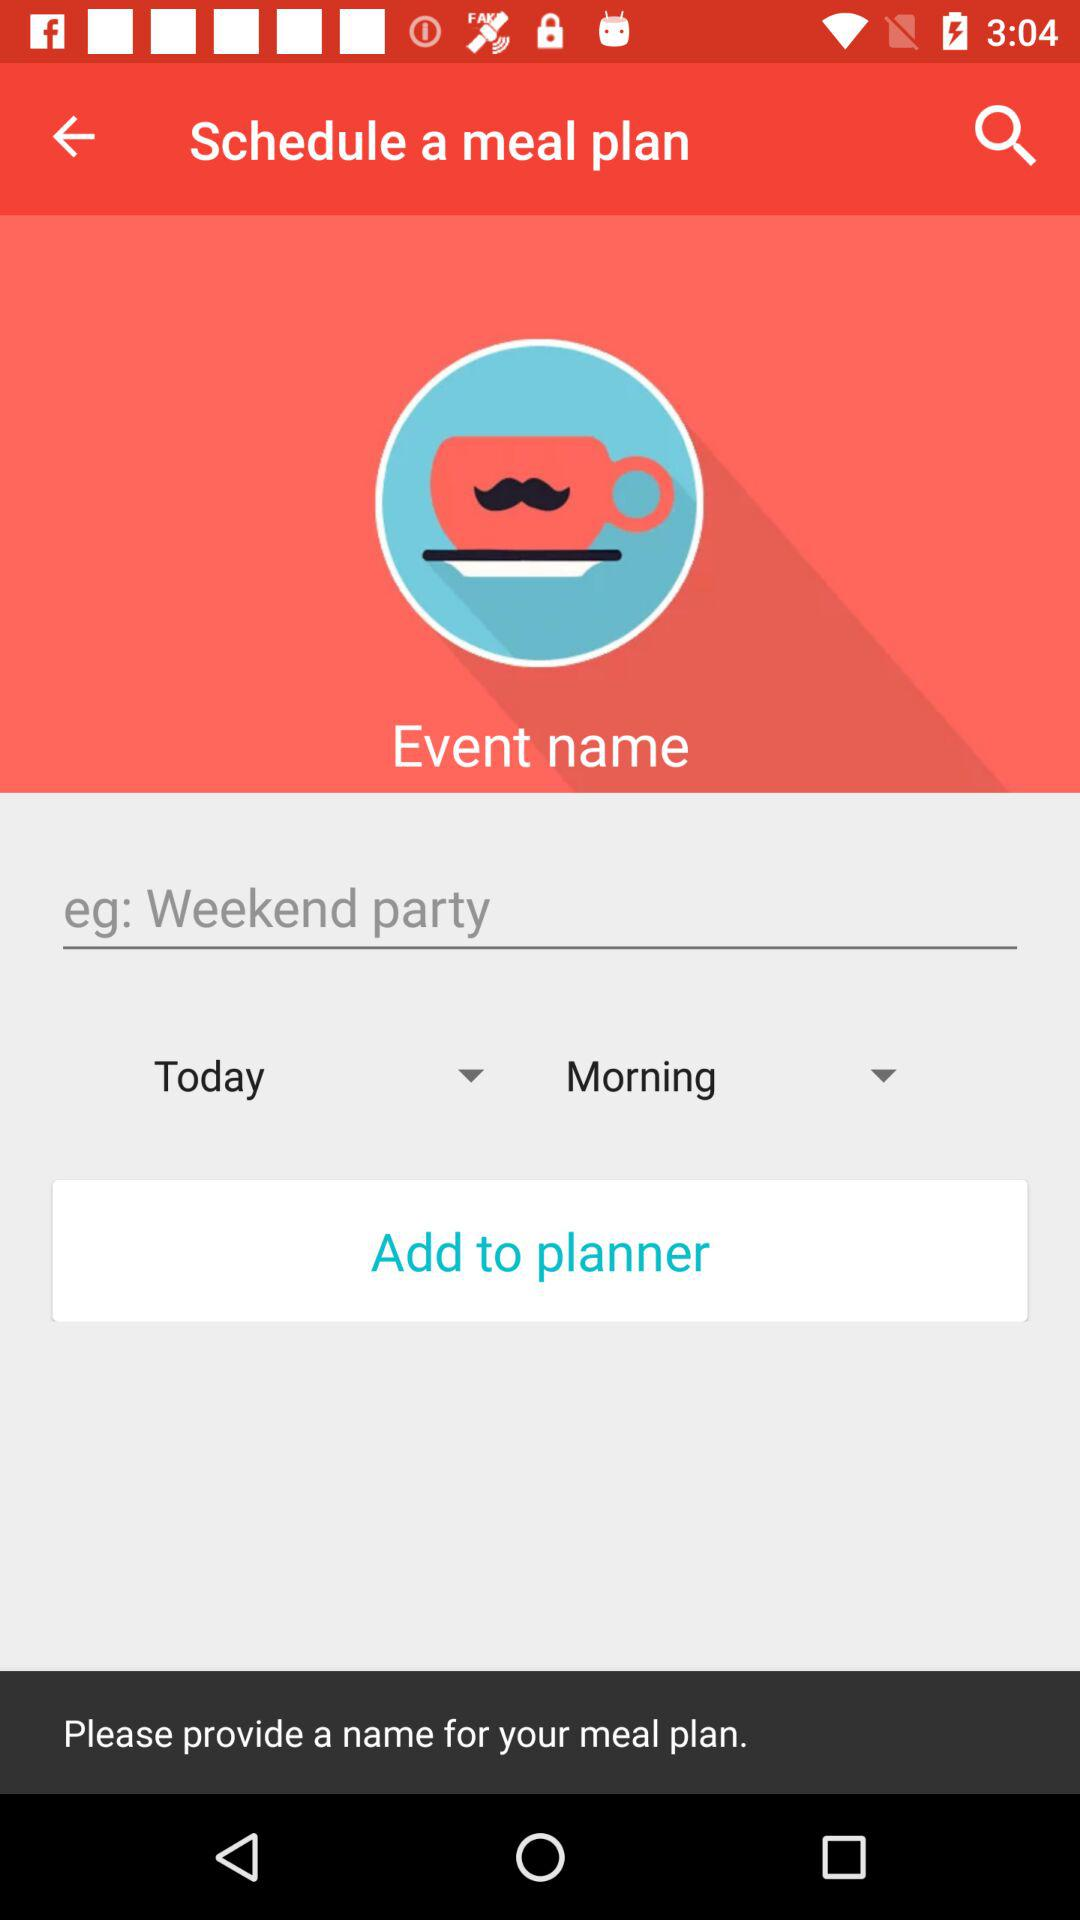Which is the selected day? The selected day is "Today". 